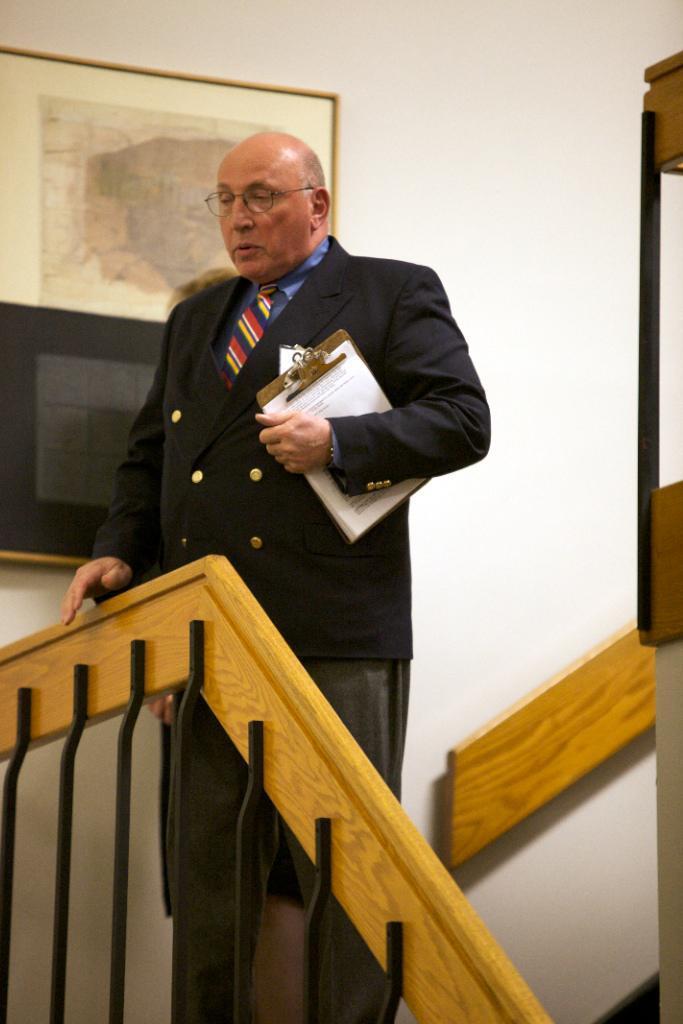Could you give a brief overview of what you see in this image? In this image we can see a person holding an object. At the bottom of the image there is a wooden texture and some iron rods. In the background of the image there is a wall, frame and other objects. 